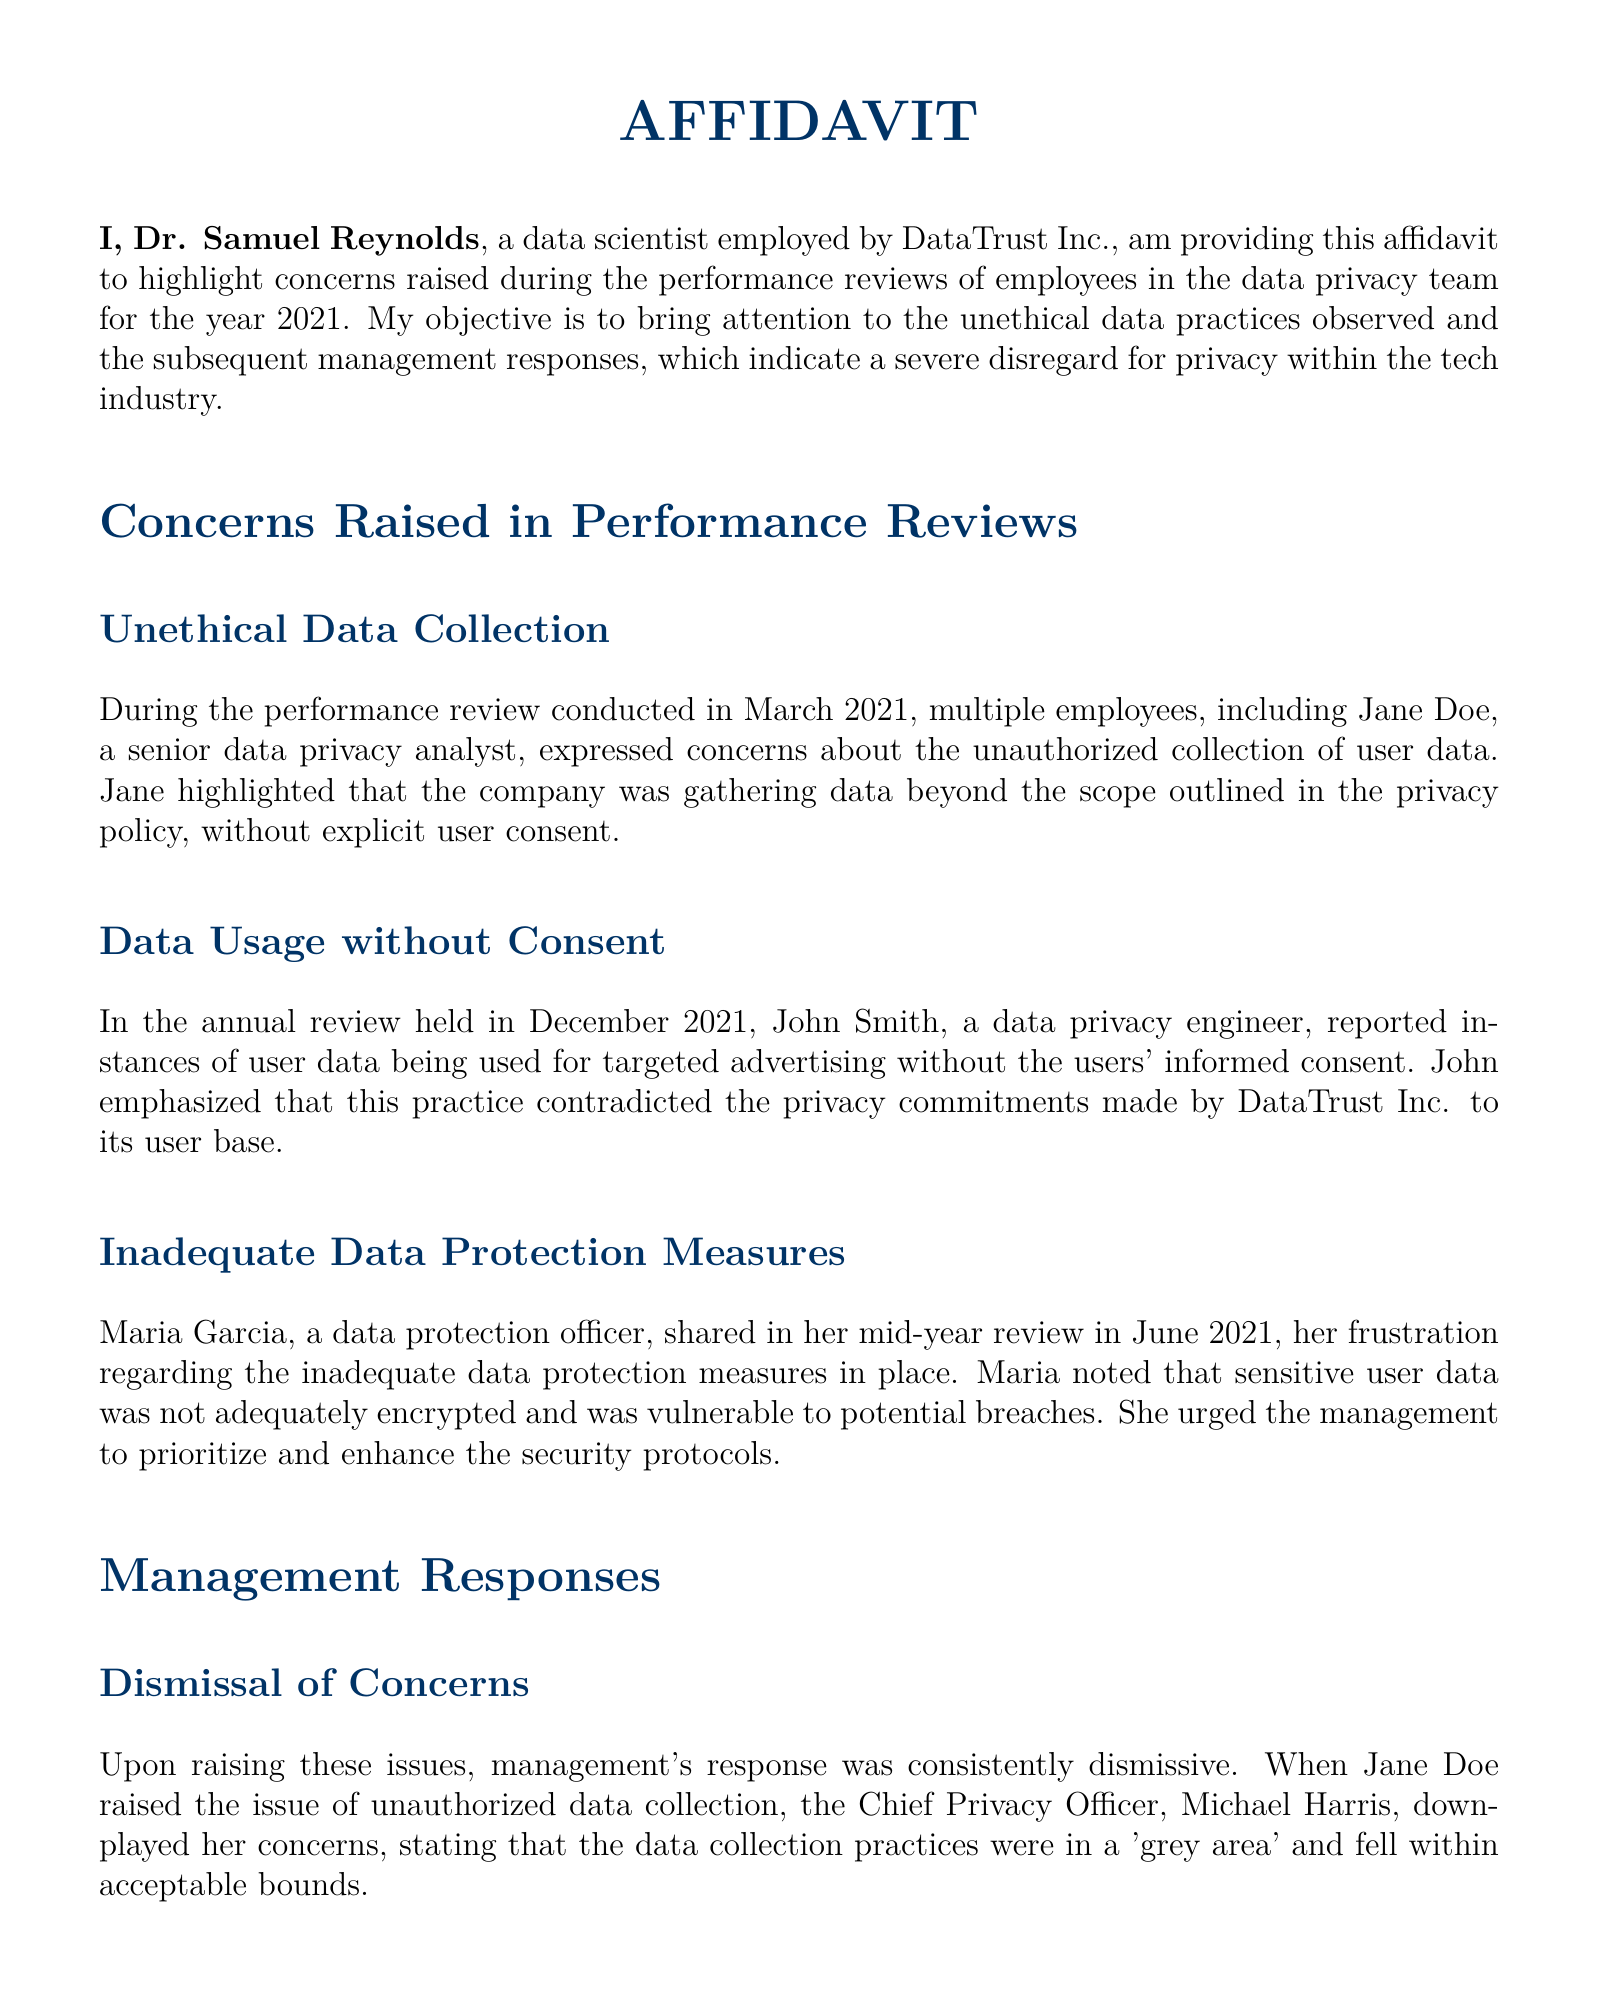what is the name of the data scientist providing the affidavit? The name of the data scientist providing the affidavit is mentioned at the beginning of the document.
Answer: Dr. Samuel Reynolds what is the date of the performance review where unethical data collection was raised? The performance review where unethical data collection was raised occurred in March 2021.
Answer: March 2021 who reported the misuse of user data for targeted advertising? The individual who reported the misuse of user data for targeted advertising is listed in the document.
Answer: John Smith what was Maria Garcia's role in the company? Maria Garcia's professional position is specified in the document, indicating her responsibilities in data management.
Answer: Data protection officer how did management respond to concerns about unauthorized data collection? The document provides a description of management's attitude toward concerns raised about unauthorized data collection.
Answer: Dismissive what were the improvements made in response to calls for better encryption? The document describes the nature of the improvements made by management, emphasizing insufficient actions taken.
Answer: Token Improvements what did John Smith feel regarding his objections to data practices? The document highlights John Smith’s feelings about his objections to unethical practices within the company.
Answer: Pressure to Conform in which month did Maria Garcia express her frustrations about data protection measures? The timing of Maria Garcia’s report regarding data protection measures is provided in the performance review context.
Answer: June 2021 who was the Chief Privacy Officer mentioned in the document? The document identifies the individual holding the position of Chief Privacy Officer during the time of the affidavit.
Answer: Michael Harris 